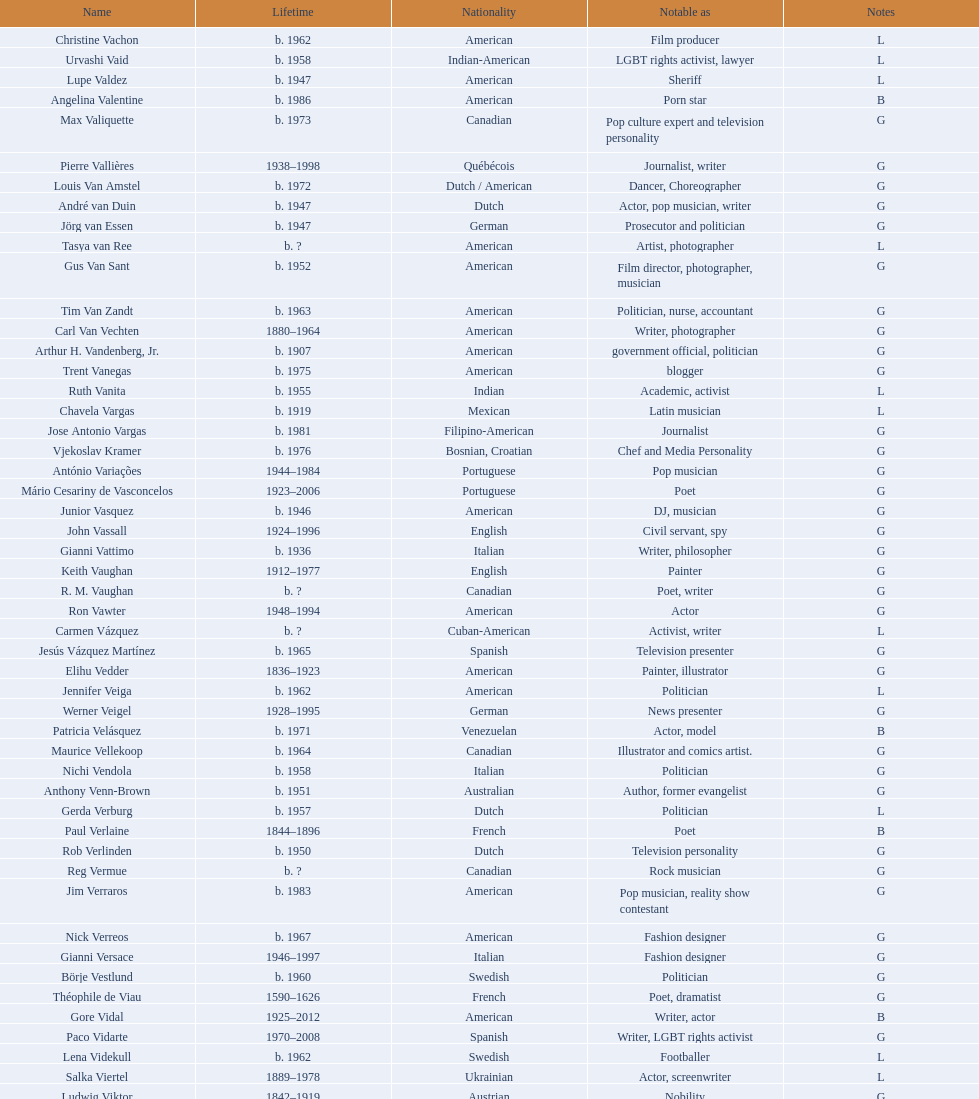What is the difference in year of borth between vachon and vaid? 4 years. Can you give me this table as a dict? {'header': ['Name', 'Lifetime', 'Nationality', 'Notable as', 'Notes'], 'rows': [['Christine Vachon', 'b. 1962', 'American', 'Film producer', 'L'], ['Urvashi Vaid', 'b. 1958', 'Indian-American', 'LGBT rights activist, lawyer', 'L'], ['Lupe Valdez', 'b. 1947', 'American', 'Sheriff', 'L'], ['Angelina Valentine', 'b. 1986', 'American', 'Porn star', 'B'], ['Max Valiquette', 'b. 1973', 'Canadian', 'Pop culture expert and television personality', 'G'], ['Pierre Vallières', '1938–1998', 'Québécois', 'Journalist, writer', 'G'], ['Louis Van Amstel', 'b. 1972', 'Dutch / American', 'Dancer, Choreographer', 'G'], ['André van Duin', 'b. 1947', 'Dutch', 'Actor, pop musician, writer', 'G'], ['Jörg van Essen', 'b. 1947', 'German', 'Prosecutor and politician', 'G'], ['Tasya van Ree', 'b.\xa0?', 'American', 'Artist, photographer', 'L'], ['Gus Van Sant', 'b. 1952', 'American', 'Film director, photographer, musician', 'G'], ['Tim Van Zandt', 'b. 1963', 'American', 'Politician, nurse, accountant', 'G'], ['Carl Van Vechten', '1880–1964', 'American', 'Writer, photographer', 'G'], ['Arthur H. Vandenberg, Jr.', 'b. 1907', 'American', 'government official, politician', 'G'], ['Trent Vanegas', 'b. 1975', 'American', 'blogger', 'G'], ['Ruth Vanita', 'b. 1955', 'Indian', 'Academic, activist', 'L'], ['Chavela Vargas', 'b. 1919', 'Mexican', 'Latin musician', 'L'], ['Jose Antonio Vargas', 'b. 1981', 'Filipino-American', 'Journalist', 'G'], ['Vjekoslav Kramer', 'b. 1976', 'Bosnian, Croatian', 'Chef and Media Personality', 'G'], ['António Variações', '1944–1984', 'Portuguese', 'Pop musician', 'G'], ['Mário Cesariny de Vasconcelos', '1923–2006', 'Portuguese', 'Poet', 'G'], ['Junior Vasquez', 'b. 1946', 'American', 'DJ, musician', 'G'], ['John Vassall', '1924–1996', 'English', 'Civil servant, spy', 'G'], ['Gianni Vattimo', 'b. 1936', 'Italian', 'Writer, philosopher', 'G'], ['Keith Vaughan', '1912–1977', 'English', 'Painter', 'G'], ['R. M. Vaughan', 'b.\xa0?', 'Canadian', 'Poet, writer', 'G'], ['Ron Vawter', '1948–1994', 'American', 'Actor', 'G'], ['Carmen Vázquez', 'b.\xa0?', 'Cuban-American', 'Activist, writer', 'L'], ['Jesús Vázquez Martínez', 'b. 1965', 'Spanish', 'Television presenter', 'G'], ['Elihu Vedder', '1836–1923', 'American', 'Painter, illustrator', 'G'], ['Jennifer Veiga', 'b. 1962', 'American', 'Politician', 'L'], ['Werner Veigel', '1928–1995', 'German', 'News presenter', 'G'], ['Patricia Velásquez', 'b. 1971', 'Venezuelan', 'Actor, model', 'B'], ['Maurice Vellekoop', 'b. 1964', 'Canadian', 'Illustrator and comics artist.', 'G'], ['Nichi Vendola', 'b. 1958', 'Italian', 'Politician', 'G'], ['Anthony Venn-Brown', 'b. 1951', 'Australian', 'Author, former evangelist', 'G'], ['Gerda Verburg', 'b. 1957', 'Dutch', 'Politician', 'L'], ['Paul Verlaine', '1844–1896', 'French', 'Poet', 'B'], ['Rob Verlinden', 'b. 1950', 'Dutch', 'Television personality', 'G'], ['Reg Vermue', 'b.\xa0?', 'Canadian', 'Rock musician', 'G'], ['Jim Verraros', 'b. 1983', 'American', 'Pop musician, reality show contestant', 'G'], ['Nick Verreos', 'b. 1967', 'American', 'Fashion designer', 'G'], ['Gianni Versace', '1946–1997', 'Italian', 'Fashion designer', 'G'], ['Börje Vestlund', 'b. 1960', 'Swedish', 'Politician', 'G'], ['Théophile de Viau', '1590–1626', 'French', 'Poet, dramatist', 'G'], ['Gore Vidal', '1925–2012', 'American', 'Writer, actor', 'B'], ['Paco Vidarte', '1970–2008', 'Spanish', 'Writer, LGBT rights activist', 'G'], ['Lena Videkull', 'b. 1962', 'Swedish', 'Footballer', 'L'], ['Salka Viertel', '1889–1978', 'Ukrainian', 'Actor, screenwriter', 'L'], ['Ludwig Viktor', '1842–1919', 'Austrian', 'Nobility', 'G'], ['Bruce Vilanch', 'b. 1948', 'American', 'Comedy writer, actor', 'G'], ['Tom Villard', '1953–1994', 'American', 'Actor', 'G'], ['José Villarrubia', 'b. 1961', 'American', 'Artist', 'G'], ['Xavier Villaurrutia', '1903–1950', 'Mexican', 'Poet, playwright', 'G'], ["Alain-Philippe Malagnac d'Argens de Villèle", '1950–2000', 'French', 'Aristocrat', 'G'], ['Norah Vincent', 'b.\xa0?', 'American', 'Journalist', 'L'], ['Donald Vining', '1917–1998', 'American', 'Writer', 'G'], ['Luchino Visconti', '1906–1976', 'Italian', 'Filmmaker', 'G'], ['Pavel Vítek', 'b. 1962', 'Czech', 'Pop musician, actor', 'G'], ['Renée Vivien', '1877–1909', 'English', 'Poet', 'L'], ['Claude Vivier', '1948–1983', 'Canadian', '20th century classical composer', 'G'], ['Taylor Vixen', 'b. 1983', 'American', 'Porn star', 'B'], ['Bruce Voeller', '1934–1994', 'American', 'HIV/AIDS researcher', 'G'], ['Paula Vogel', 'b. 1951', 'American', 'Playwright', 'L'], ['Julia Volkova', 'b. 1985', 'Russian', 'Singer', 'B'], ['Jörg van Essen', 'b. 1947', 'German', 'Politician', 'G'], ['Ole von Beust', 'b. 1955', 'German', 'Politician', 'G'], ['Wilhelm von Gloeden', '1856–1931', 'German', 'Photographer', 'G'], ['Rosa von Praunheim', 'b. 1942', 'German', 'Film director', 'G'], ['Kurt von Ruffin', 'b. 1901–1996', 'German', 'Holocaust survivor', 'G'], ['Hella von Sinnen', 'b. 1959', 'German', 'Comedian', 'L'], ['Daniel Vosovic', 'b. 1981', 'American', 'Fashion designer', 'G'], ['Delwin Vriend', 'b. 1966', 'Canadian', 'LGBT rights activist', 'G']]} 